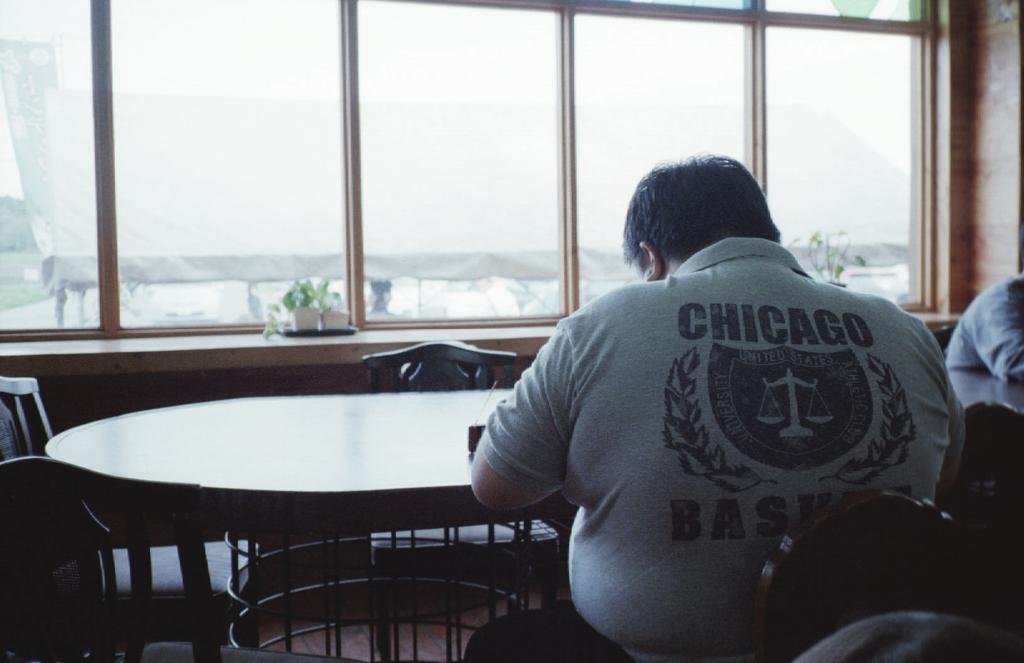What type of furniture is present in the image? There is a table and chairs in the image. Can you describe the position of the person in the image? A person is sitting on a chair in the bottom right of the image. What is visible at the top of the image? There is a window at the top of the image. How many dogs are participating in the event depicted in the image? There is no event or dogs present in the image. What type of crack is visible on the table in the image? There is no crack visible on the table in the image. 